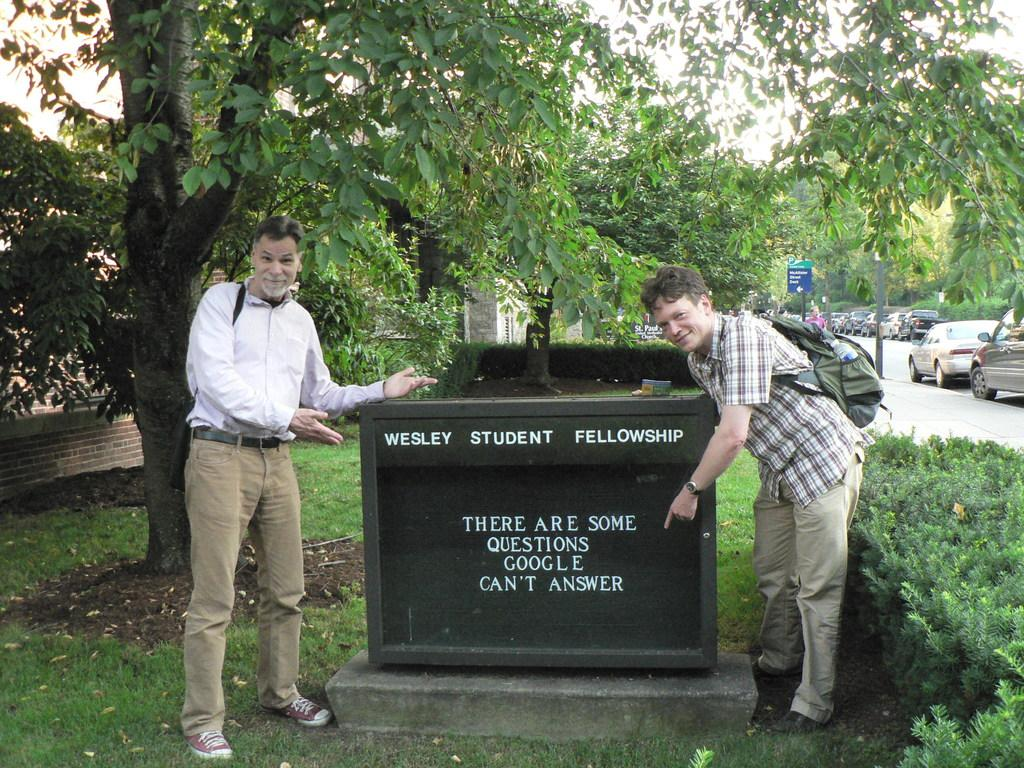What is the primary activity of the men in the image? The men are standing on the ground in the image. What type of vegetation can be seen in the image? Shredded leaves, bushes, and trees are visible in the image. What type of transportation is present in the image? Motor vehicles are on the road in the image. What type of signage is present in the image? Sign boards and information boards are present in the image. What type of structures are visible in the image? Buildings are present in the image. What part of the natural environment is visible in the image? The sky is visible in the image. What verse is being recited by the beggar in the image? There is no beggar present in the image, and therefore no verse can be heard. What story is being told by the beggar in the image? There is no beggar present in the image, and therefore no story can be told. 